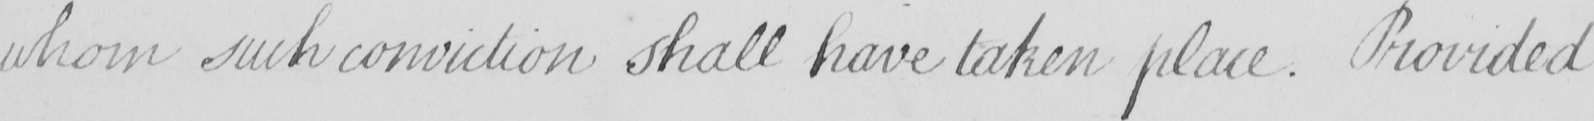Transcribe the text shown in this historical manuscript line. whom such conviction shall have taken place . Provided 